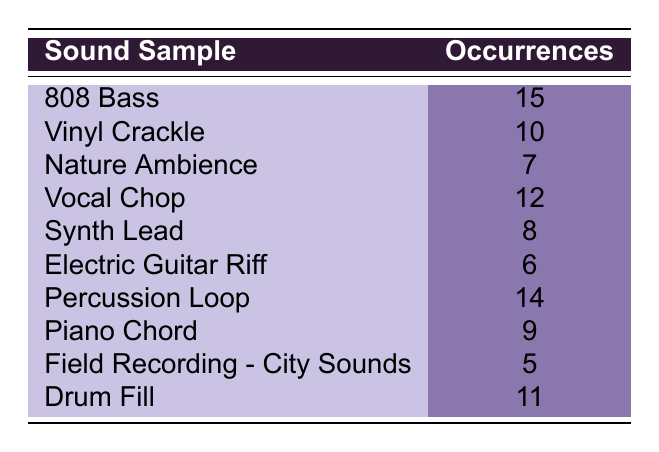What is the occurrence of the 808 Bass sample? The table lists the '808 Bass' under the sound samples with a corresponding occurrence of 15.
Answer: 15 Which sound sample has the highest occurrence? By examining the occurrences listed, '808 Bass' has the highest value of 15 compared to the other samples.
Answer: 808 Bass How many sound samples have occurrences greater than 10? The samples with occurrences greater than 10 are '808 Bass' (15), 'Vocal Chop' (12), 'Drum Fill' (11), and 'Percussion Loop' (14). That is a total of 4 samples.
Answer: 4 What is the total number of occurrences of samples that have a value of 8 or less? The samples with occurrences of 8 or less are 'Electric Guitar Riff' (6), 'Nature Ambience' (7), 'Synth Lead' (8), and 'Field Recording - City Sounds' (5). Their total is 6 + 7 + 8 + 5 = 26.
Answer: 26 Is it true that the Vocal Chop sample appears more often than the Vinyl Crackle sample? The table shows that 'Vocal Chop' has 12 occurrences while 'Vinyl Crackle' has 10, indicating that it is indeed true.
Answer: Yes What is the average occurrence of all the sound samples? To find the average, we first sum all the occurrences: 15 + 10 + 7 + 12 + 8 + 6 + 14 + 9 + 5 + 11 = 87. Since there are 10 samples, the average is 87 / 10 = 8.7.
Answer: 8.7 What is the difference in occurrences between the most and least frequent samples? The most frequent sample is '808 Bass' with 15 occurrences, and the least frequent is 'Field Recording - City Sounds' with 5 occurrences. The difference is 15 - 5 = 10.
Answer: 10 Are there any sound samples with exactly 9 occurrences? The table shows 'Piano Chord' with 9 occurrences, confirming that there is at least one sample that meets this condition.
Answer: Yes Count the number of unique sound samples that have occurrences between 6 and 10 (inclusive). The samples fitting this range are 'Vinyl Crackle' (10), 'Piano Chord' (9), 'Synth Lead' (8), and 'Electric Guitar Riff' (6). That totals 4 samples.
Answer: 4 